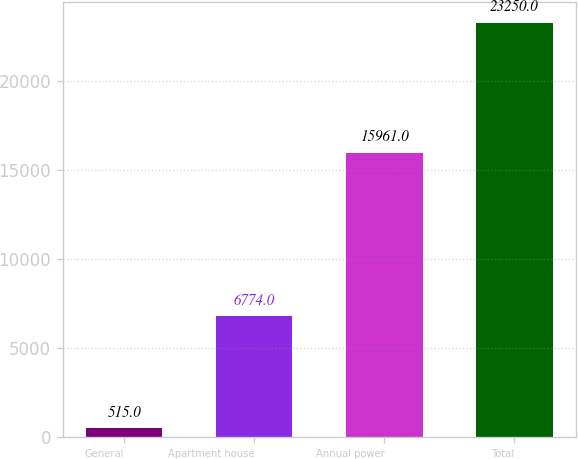Convert chart. <chart><loc_0><loc_0><loc_500><loc_500><bar_chart><fcel>General<fcel>Apartment house<fcel>Annual power<fcel>Total<nl><fcel>515<fcel>6774<fcel>15961<fcel>23250<nl></chart> 